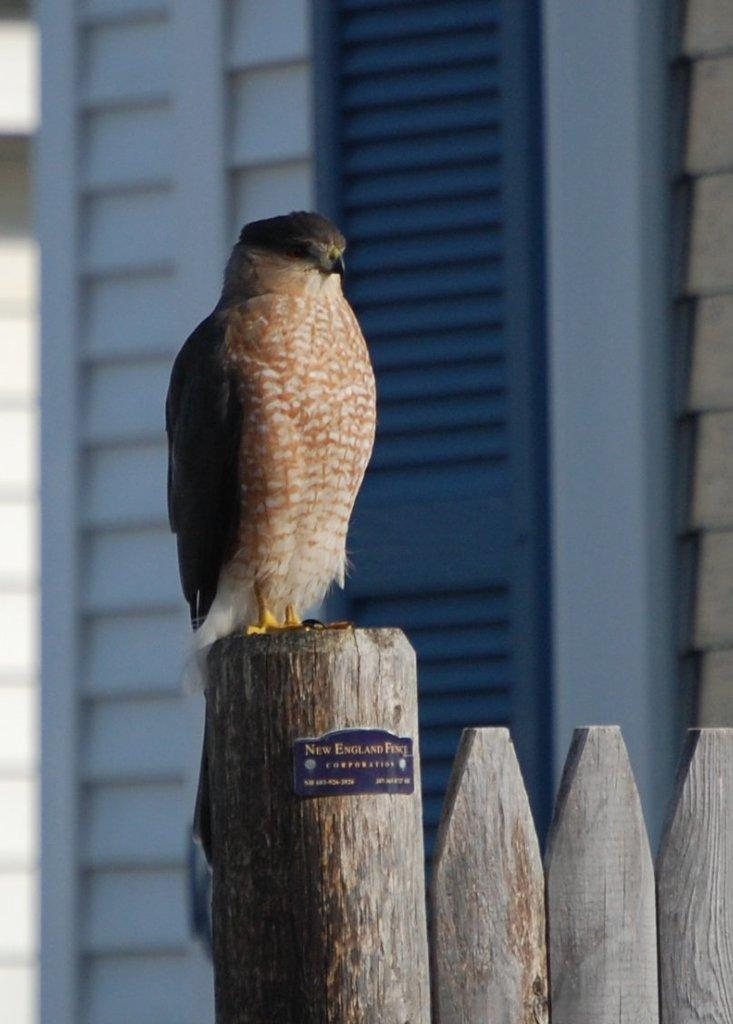What type of animal is in the image? There is a bird in the image. What is the bird standing on? The bird is standing on wood. What can be seen in the background of the image? There is a building in the background of the image. What type of work does the bird's brother do in the image? There is no mention of a brother or work in the image; it only features a bird standing on wood with a building in the background. 